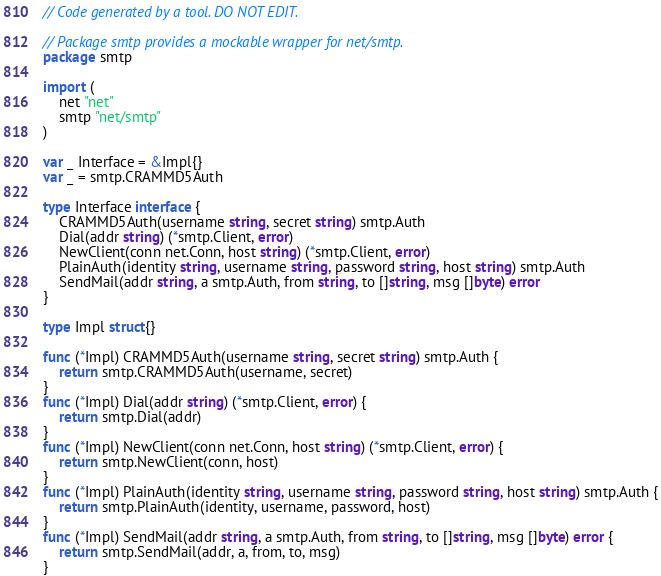Convert code to text. <code><loc_0><loc_0><loc_500><loc_500><_Go_>// Code generated by a tool. DO NOT EDIT.

// Package smtp provides a mockable wrapper for net/smtp.
package smtp

import (
	net "net"
	smtp "net/smtp"
)

var _ Interface = &Impl{}
var _ = smtp.CRAMMD5Auth

type Interface interface {
	CRAMMD5Auth(username string, secret string) smtp.Auth
	Dial(addr string) (*smtp.Client, error)
	NewClient(conn net.Conn, host string) (*smtp.Client, error)
	PlainAuth(identity string, username string, password string, host string) smtp.Auth
	SendMail(addr string, a smtp.Auth, from string, to []string, msg []byte) error
}

type Impl struct{}

func (*Impl) CRAMMD5Auth(username string, secret string) smtp.Auth {
	return smtp.CRAMMD5Auth(username, secret)
}
func (*Impl) Dial(addr string) (*smtp.Client, error) {
	return smtp.Dial(addr)
}
func (*Impl) NewClient(conn net.Conn, host string) (*smtp.Client, error) {
	return smtp.NewClient(conn, host)
}
func (*Impl) PlainAuth(identity string, username string, password string, host string) smtp.Auth {
	return smtp.PlainAuth(identity, username, password, host)
}
func (*Impl) SendMail(addr string, a smtp.Auth, from string, to []string, msg []byte) error {
	return smtp.SendMail(addr, a, from, to, msg)
}
</code> 